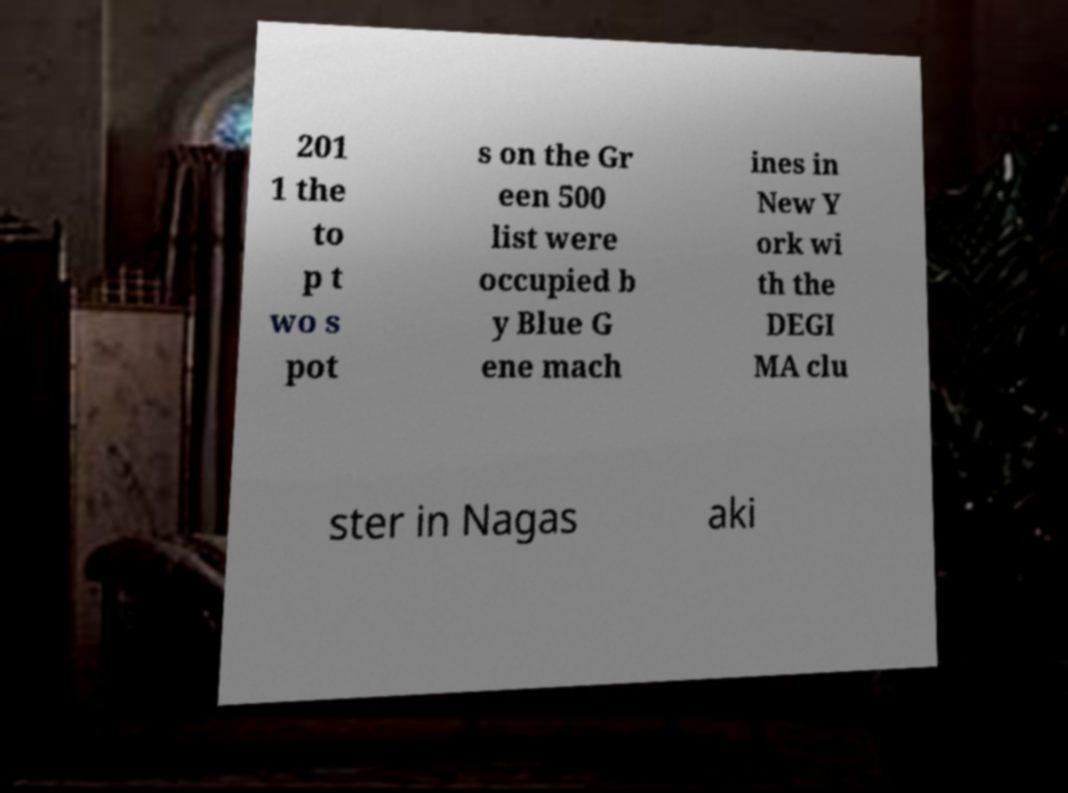For documentation purposes, I need the text within this image transcribed. Could you provide that? 201 1 the to p t wo s pot s on the Gr een 500 list were occupied b y Blue G ene mach ines in New Y ork wi th the DEGI MA clu ster in Nagas aki 